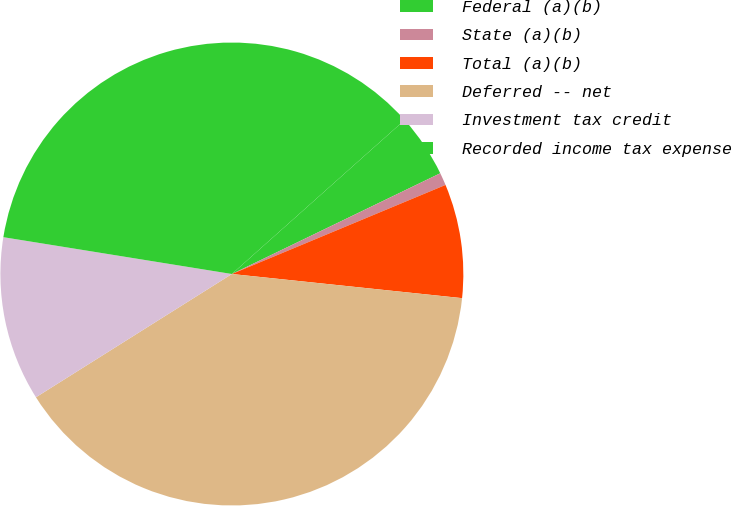Convert chart to OTSL. <chart><loc_0><loc_0><loc_500><loc_500><pie_chart><fcel>Federal (a)(b)<fcel>State (a)(b)<fcel>Total (a)(b)<fcel>Deferred -- net<fcel>Investment tax credit<fcel>Recorded income tax expense<nl><fcel>4.42%<fcel>0.88%<fcel>7.95%<fcel>39.4%<fcel>11.48%<fcel>35.87%<nl></chart> 